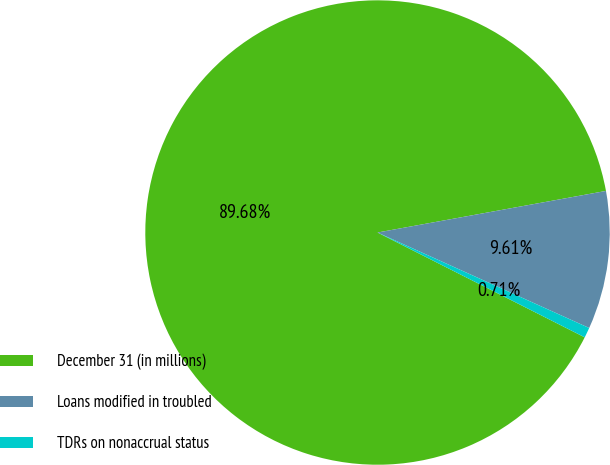Convert chart to OTSL. <chart><loc_0><loc_0><loc_500><loc_500><pie_chart><fcel>December 31 (in millions)<fcel>Loans modified in troubled<fcel>TDRs on nonaccrual status<nl><fcel>89.68%<fcel>9.61%<fcel>0.71%<nl></chart> 